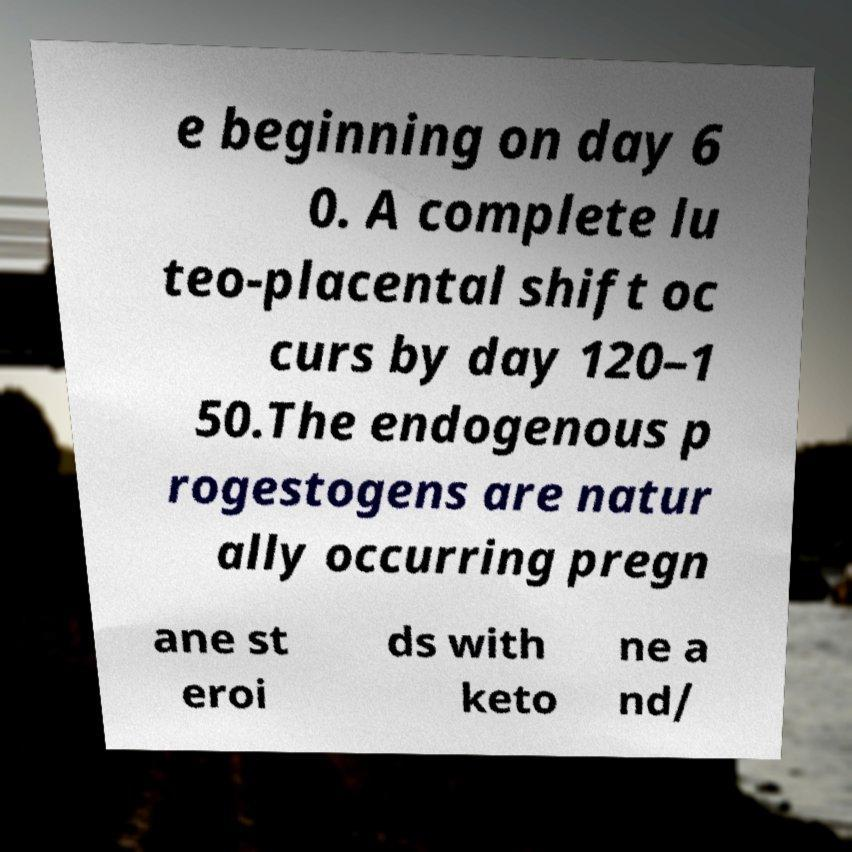Can you read and provide the text displayed in the image?This photo seems to have some interesting text. Can you extract and type it out for me? e beginning on day 6 0. A complete lu teo-placental shift oc curs by day 120–1 50.The endogenous p rogestogens are natur ally occurring pregn ane st eroi ds with keto ne a nd/ 